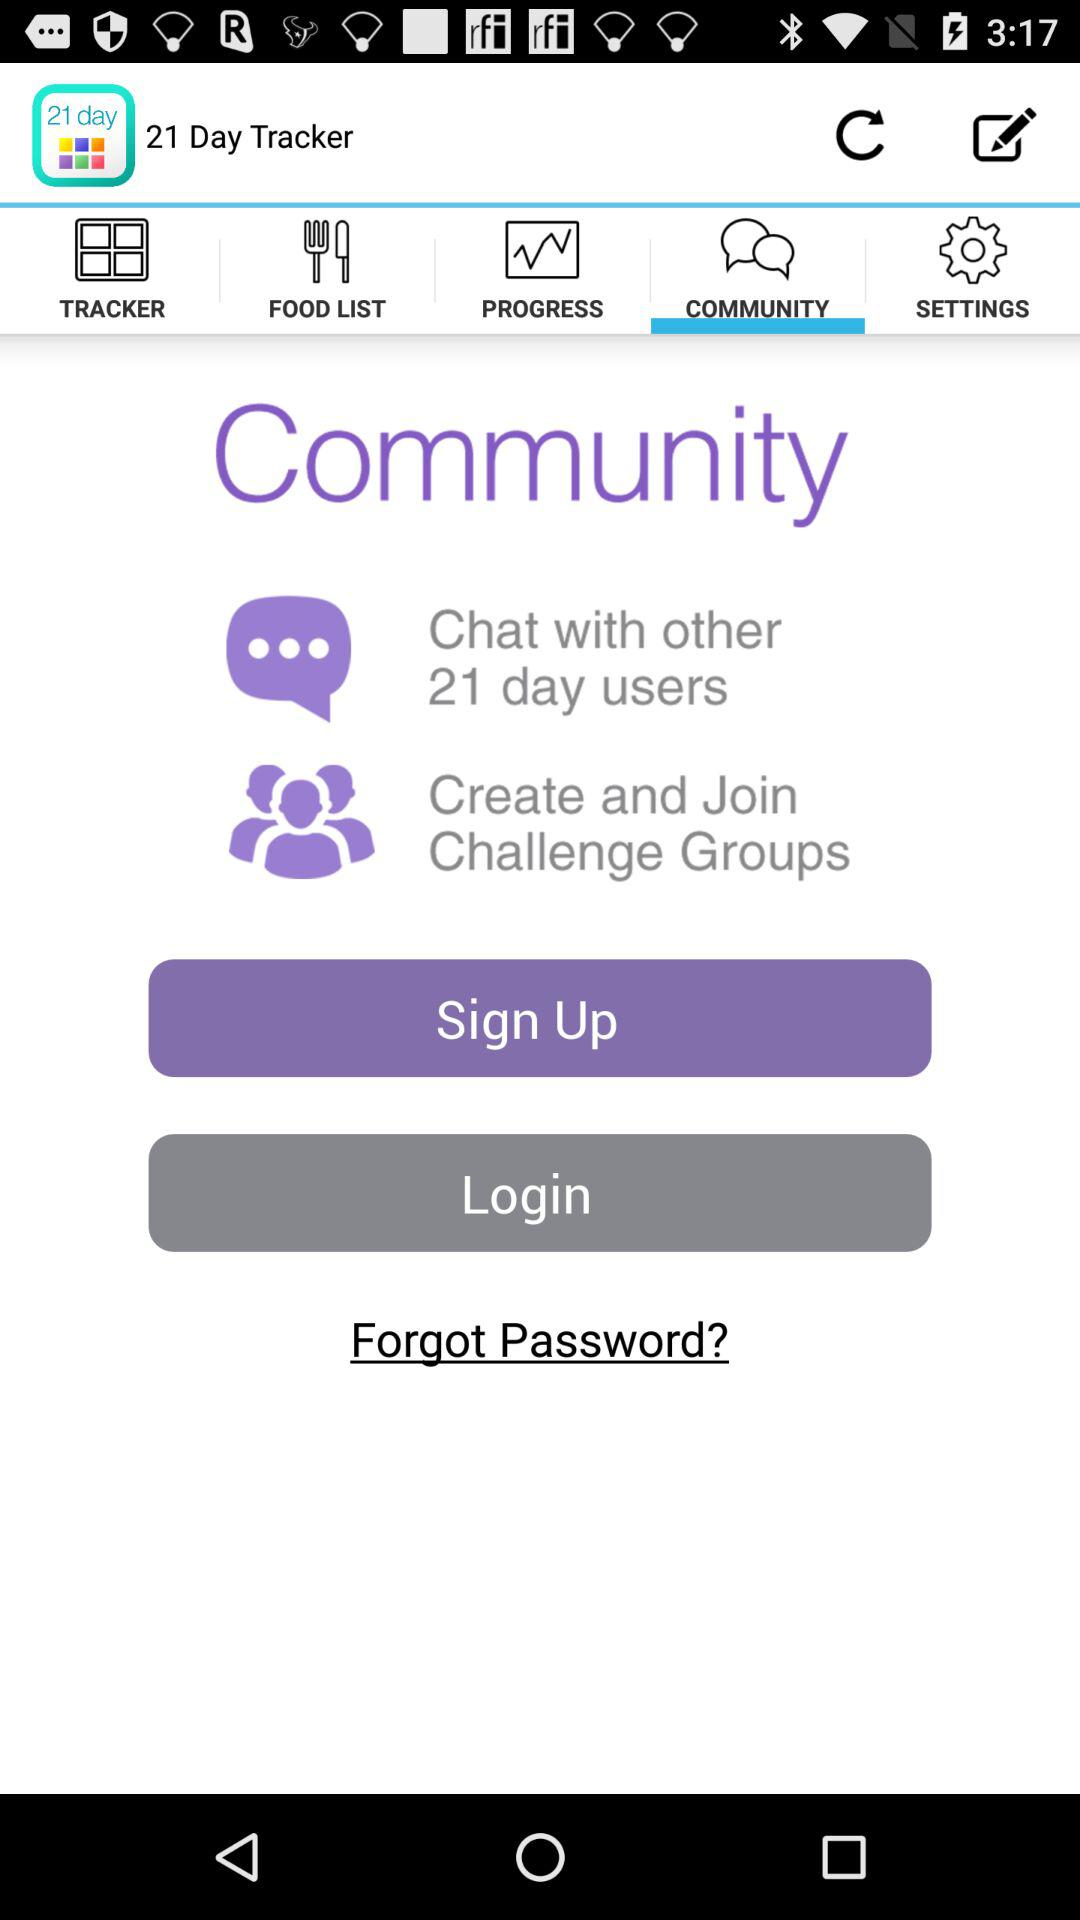The tracker is for how many days?
When the provided information is insufficient, respond with <no answer>. <no answer> 